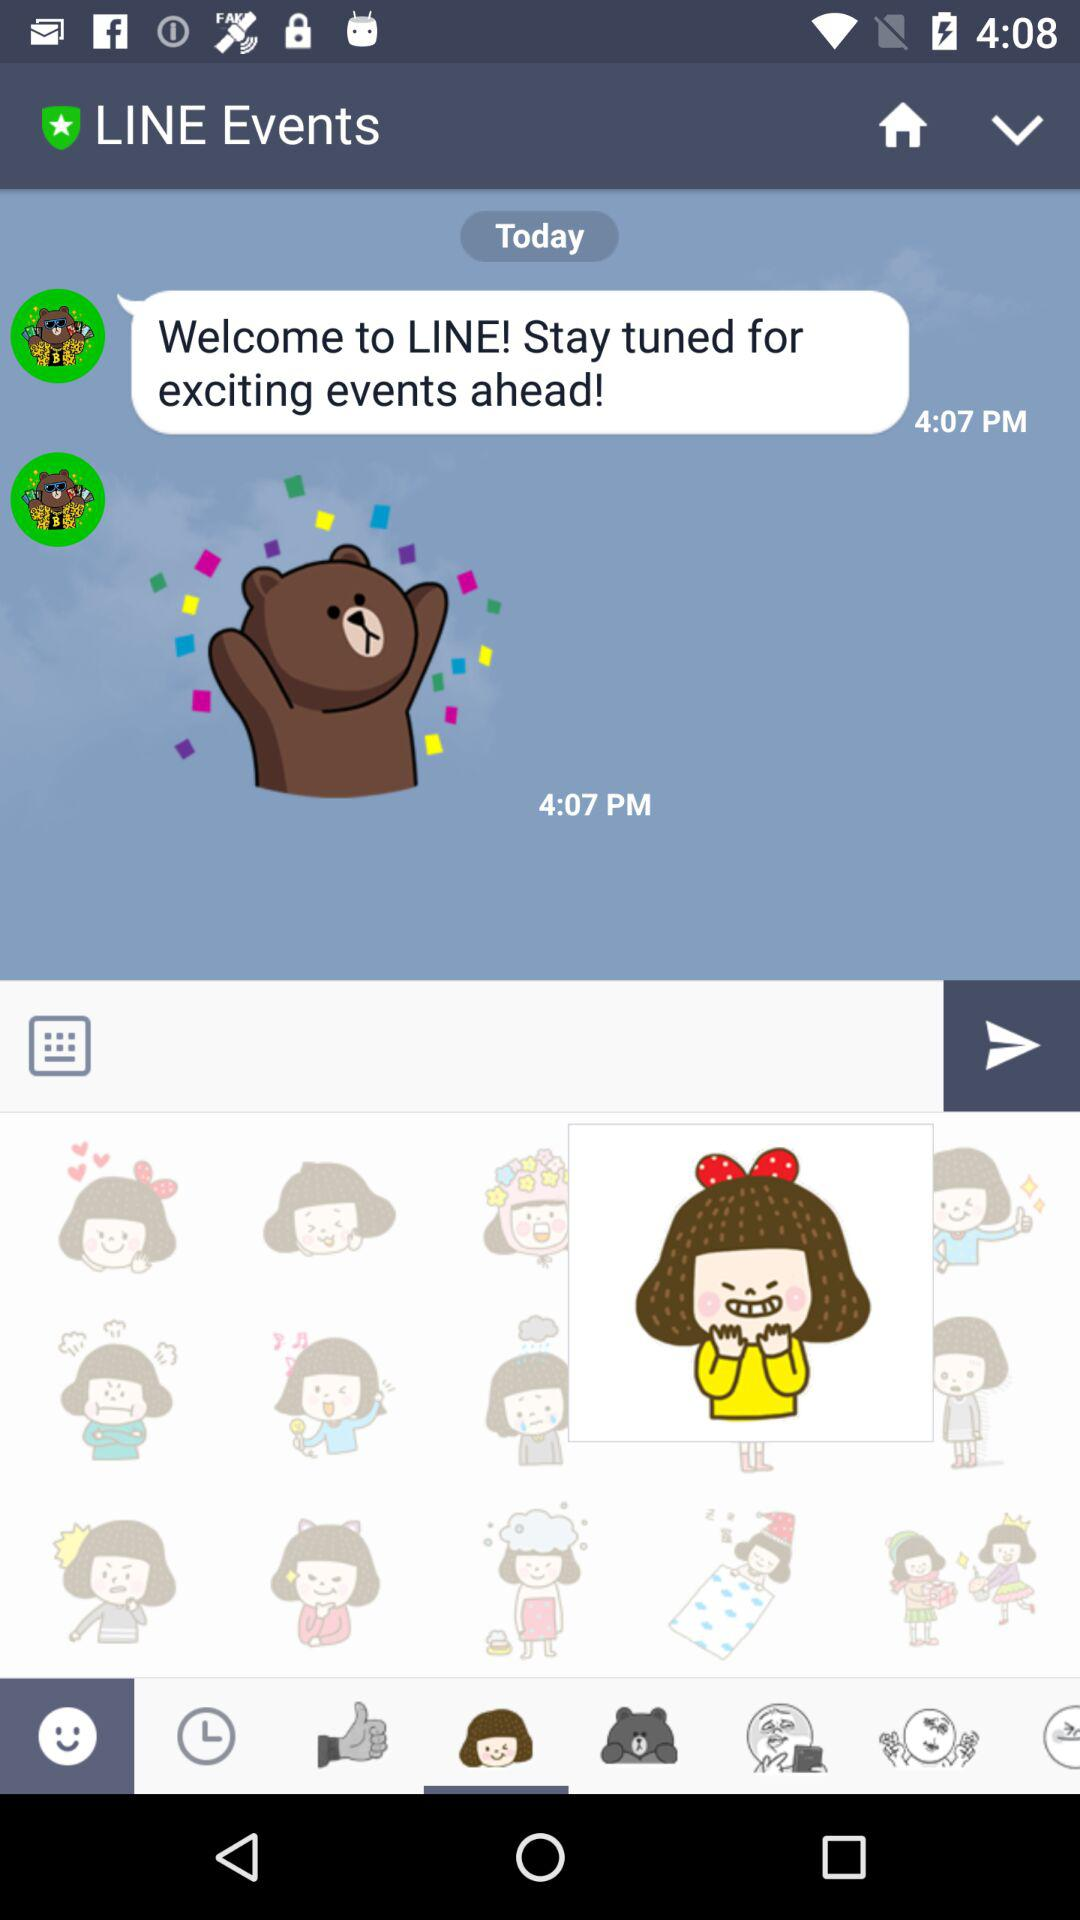What is the name of the application? The name of the application is "LINE Events". 